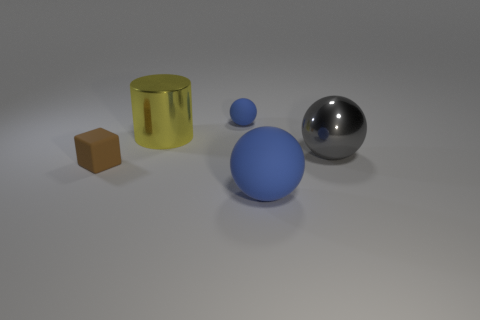Could you guess the relative sizes of these objects? From the perspective of the image, it is clear that the blue sphere is notably larger than the other objects. The reflective sphere, while smaller than the blue one, is likely larger in diameter than the yellow cylinder. The cube is the smallest object in the set, with its dimensions being less than the diameter of the spheres. 